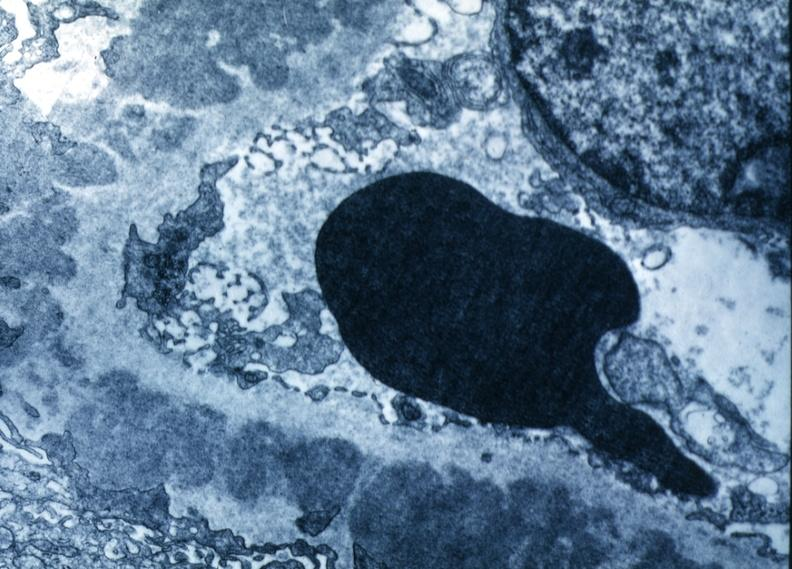what does this image show?
Answer the question using a single word or phrase. Excellent to show thickened basement membrane and immune complexes same case as 